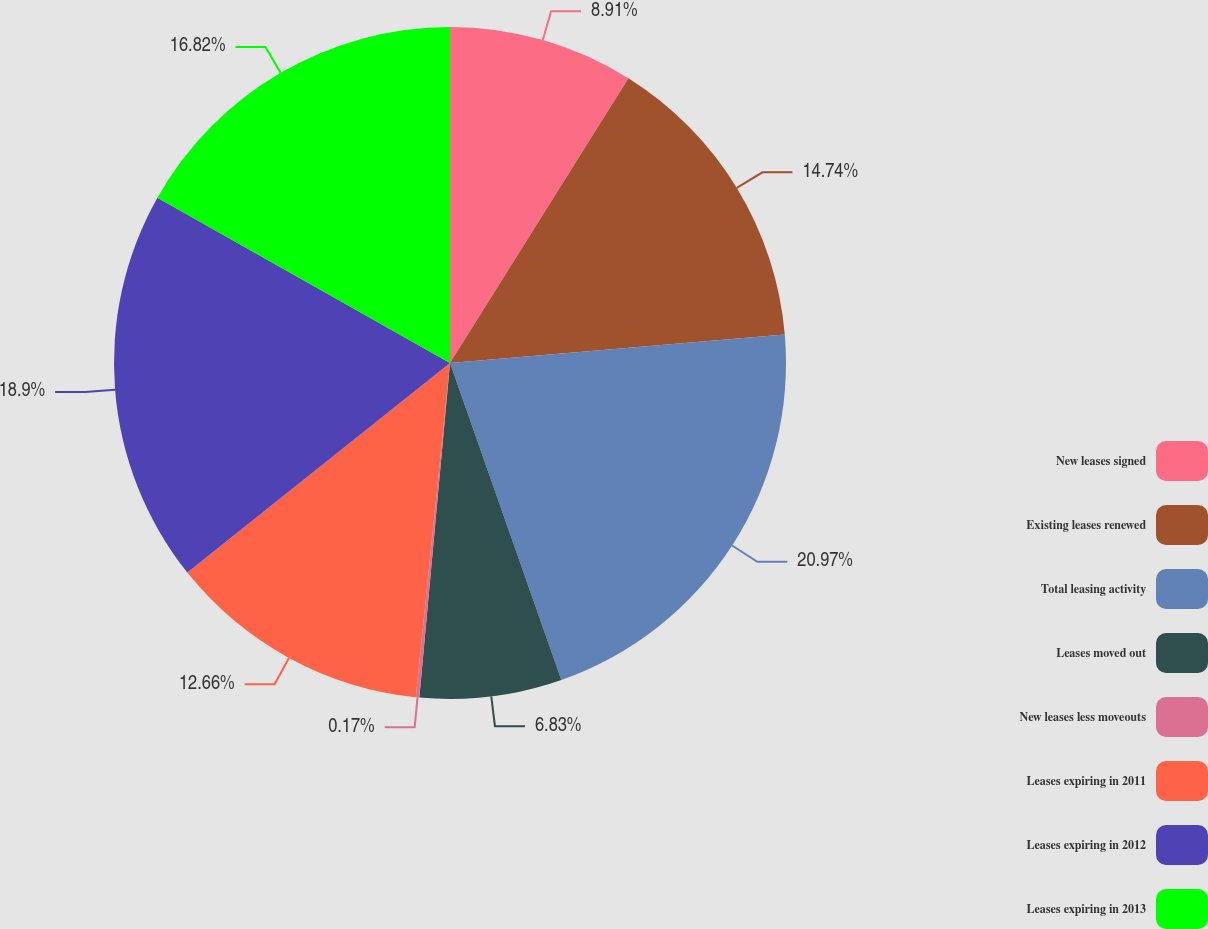<chart> <loc_0><loc_0><loc_500><loc_500><pie_chart><fcel>New leases signed<fcel>Existing leases renewed<fcel>Total leasing activity<fcel>Leases moved out<fcel>New leases less moveouts<fcel>Leases expiring in 2011<fcel>Leases expiring in 2012<fcel>Leases expiring in 2013<nl><fcel>8.91%<fcel>14.74%<fcel>20.98%<fcel>6.83%<fcel>0.17%<fcel>12.66%<fcel>18.9%<fcel>16.82%<nl></chart> 